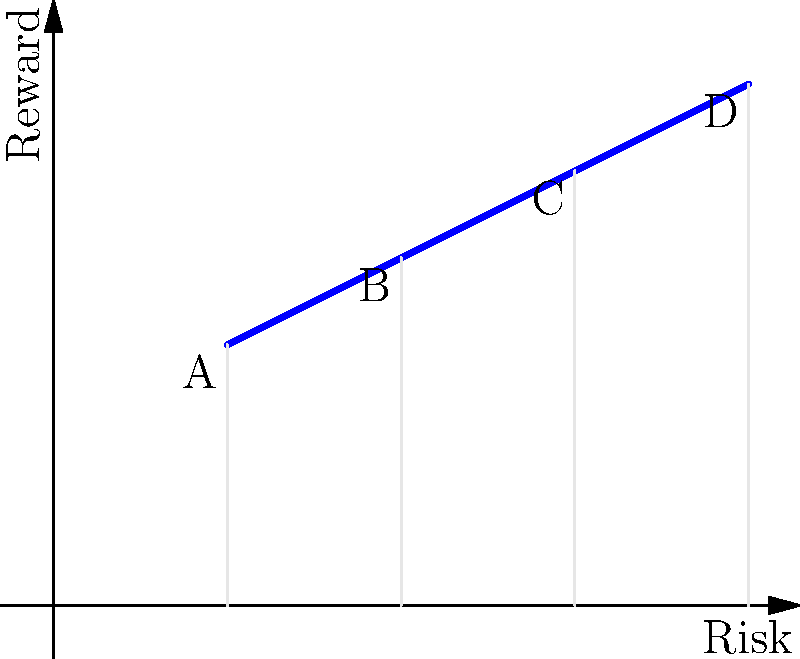Based on the risk-reward bar chart above, which trade has the highest risk-reward ratio? Calculate the ratios for all trades and explain your reasoning. To solve this problem, we need to calculate the risk-reward ratio for each trade and compare them. The risk-reward ratio is calculated as Reward / Risk.

Step 1: Calculate the risk-reward ratio for each trade:

Trade A: Reward = 1.5, Risk = 1
Ratio A = 1.5 / 1 = 1.5

Trade B: Reward = 2, Risk = 2
Ratio B = 2 / 2 = 1

Trade C: Reward = 2.5, Risk = 3
Ratio C = 2.5 / 3 ≈ 0.833

Trade D: Reward = 3, Risk = 4
Ratio D = 3 / 4 = 0.75

Step 2: Compare the ratios:
A: 1.5
B: 1
C: 0.833
D: 0.75

Step 3: Identify the highest ratio:
The highest ratio is 1.5, which corresponds to Trade A.

This means that for every unit of risk taken in Trade A, the potential reward is 1.5 units, making it the most favorable risk-reward ratio among the given trades.
Answer: Trade A with a risk-reward ratio of 1.5 